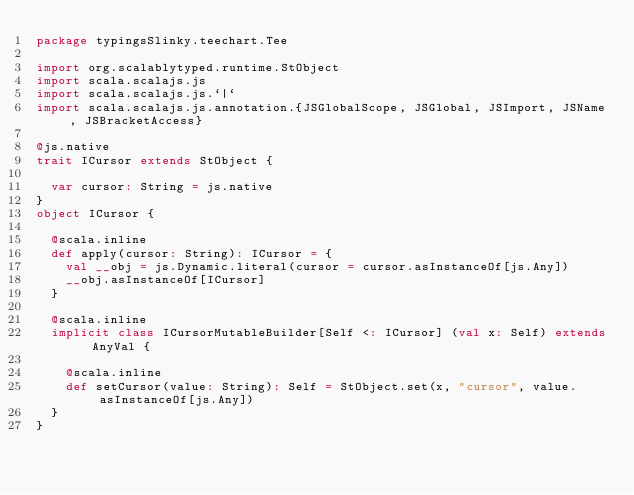<code> <loc_0><loc_0><loc_500><loc_500><_Scala_>package typingsSlinky.teechart.Tee

import org.scalablytyped.runtime.StObject
import scala.scalajs.js
import scala.scalajs.js.`|`
import scala.scalajs.js.annotation.{JSGlobalScope, JSGlobal, JSImport, JSName, JSBracketAccess}

@js.native
trait ICursor extends StObject {
  
  var cursor: String = js.native
}
object ICursor {
  
  @scala.inline
  def apply(cursor: String): ICursor = {
    val __obj = js.Dynamic.literal(cursor = cursor.asInstanceOf[js.Any])
    __obj.asInstanceOf[ICursor]
  }
  
  @scala.inline
  implicit class ICursorMutableBuilder[Self <: ICursor] (val x: Self) extends AnyVal {
    
    @scala.inline
    def setCursor(value: String): Self = StObject.set(x, "cursor", value.asInstanceOf[js.Any])
  }
}
</code> 